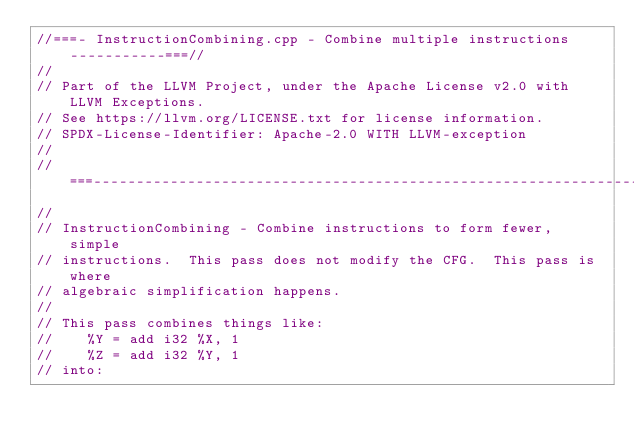Convert code to text. <code><loc_0><loc_0><loc_500><loc_500><_C++_>//===- InstructionCombining.cpp - Combine multiple instructions -----------===//
//
// Part of the LLVM Project, under the Apache License v2.0 with LLVM Exceptions.
// See https://llvm.org/LICENSE.txt for license information.
// SPDX-License-Identifier: Apache-2.0 WITH LLVM-exception
//
//===----------------------------------------------------------------------===//
//
// InstructionCombining - Combine instructions to form fewer, simple
// instructions.  This pass does not modify the CFG.  This pass is where
// algebraic simplification happens.
//
// This pass combines things like:
//    %Y = add i32 %X, 1
//    %Z = add i32 %Y, 1
// into:</code> 